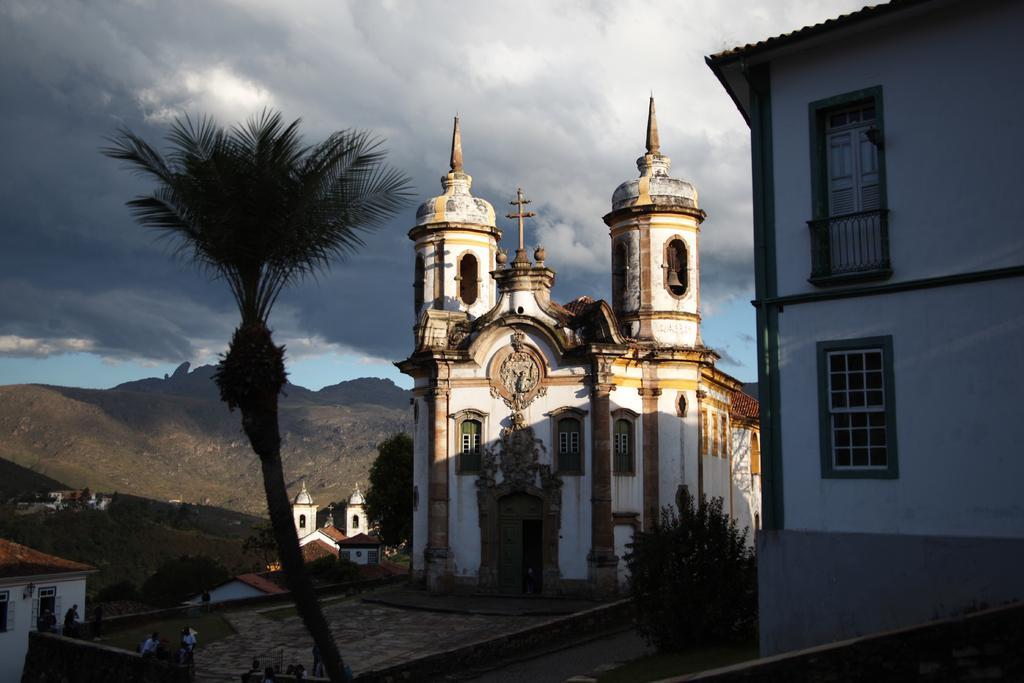In one or two sentences, can you explain what this image depicts? In this picture we can see houses, plants, trees, and few people. In the background we can see a mountain and sky with clouds. 